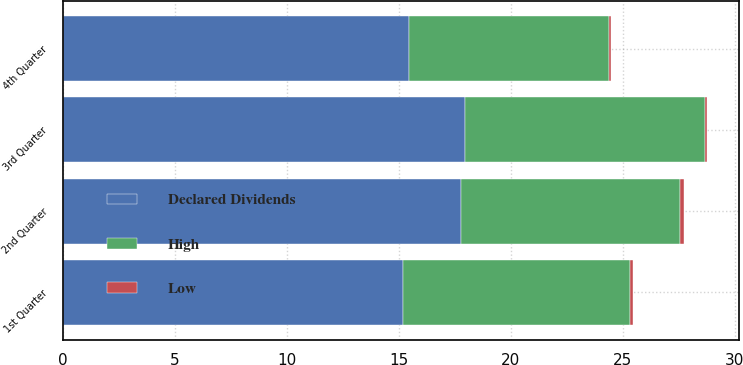Convert chart to OTSL. <chart><loc_0><loc_0><loc_500><loc_500><stacked_bar_chart><ecel><fcel>1st Quarter<fcel>2nd Quarter<fcel>3rd Quarter<fcel>4th Quarter<nl><fcel>Declared Dividends<fcel>15.18<fcel>17.8<fcel>17.95<fcel>15.46<nl><fcel>High<fcel>10.15<fcel>9.78<fcel>10.74<fcel>8.93<nl><fcel>Low<fcel>0.15<fcel>0.15<fcel>0.07<fcel>0.07<nl></chart> 